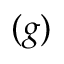<formula> <loc_0><loc_0><loc_500><loc_500>( g )</formula> 